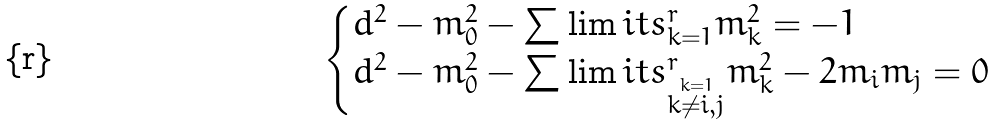Convert formula to latex. <formula><loc_0><loc_0><loc_500><loc_500>\begin{cases} d ^ { 2 } - m _ { 0 } ^ { 2 } - \sum \lim i t s _ { k = 1 } ^ { r } m _ { k } ^ { 2 } = - 1 & \\ d ^ { 2 } - m _ { 0 } ^ { 2 } - \sum \lim i t s _ { \stackrel { k = 1 } { k \neq i , j } } ^ { r } m _ { k } ^ { 2 } - 2 m _ { i } m _ { j } = 0 & \end{cases}</formula> 